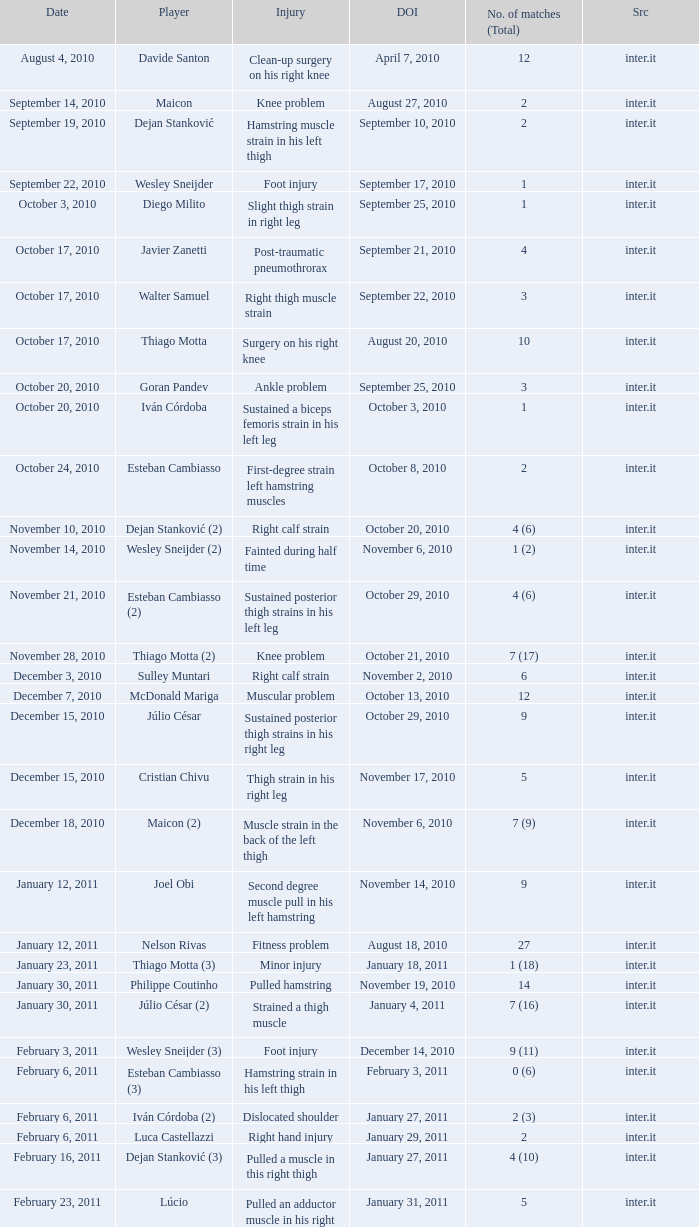How many times was the date october 3, 2010? 1.0. 